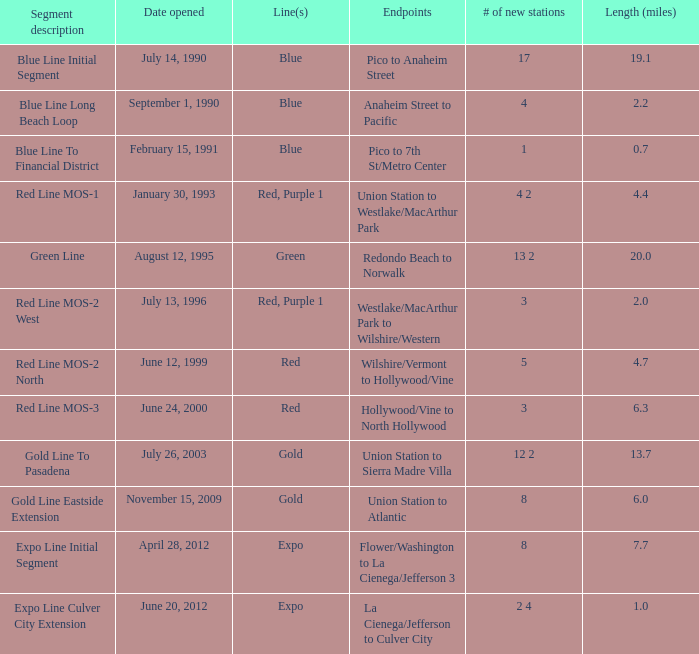How many news stations opened on the date of June 24, 2000? 3.0. 